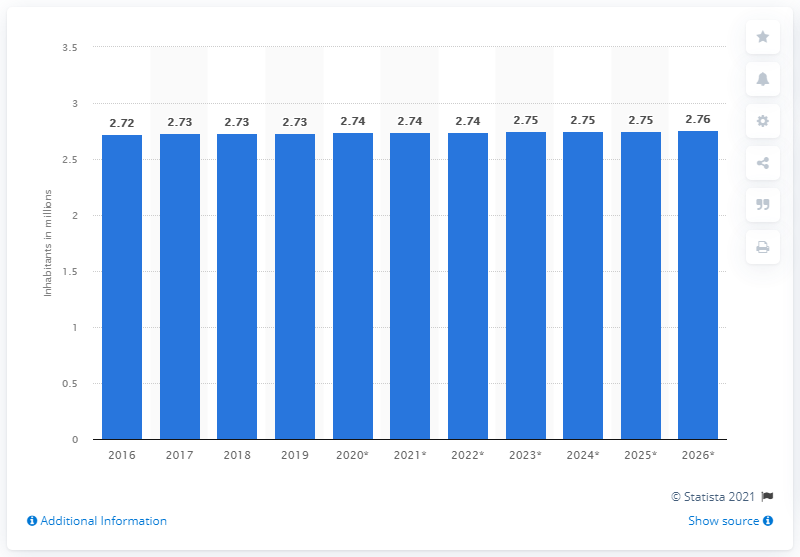Identify some key points in this picture. The population of Jamaica in 2019 was approximately 2.75 million people. 